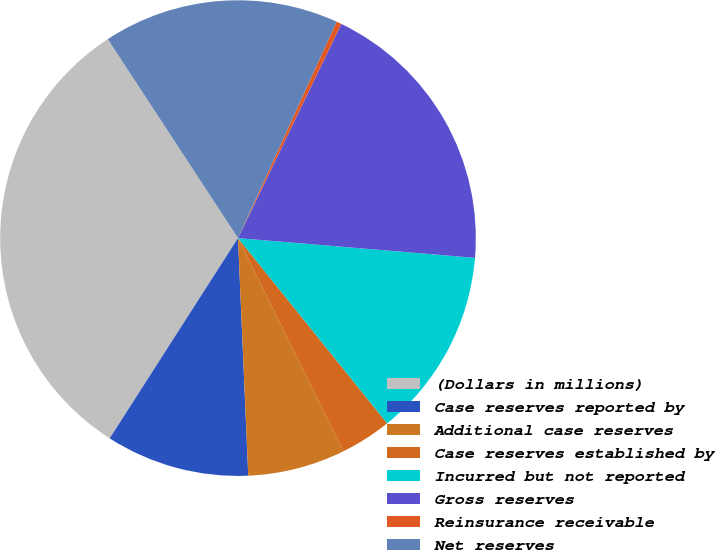Convert chart. <chart><loc_0><loc_0><loc_500><loc_500><pie_chart><fcel>(Dollars in millions)<fcel>Case reserves reported by<fcel>Additional case reserves<fcel>Case reserves established by<fcel>Incurred but not reported<fcel>Gross reserves<fcel>Reinsurance receivable<fcel>Net reserves<nl><fcel>31.71%<fcel>9.76%<fcel>6.62%<fcel>3.48%<fcel>12.89%<fcel>19.17%<fcel>0.35%<fcel>16.03%<nl></chart> 